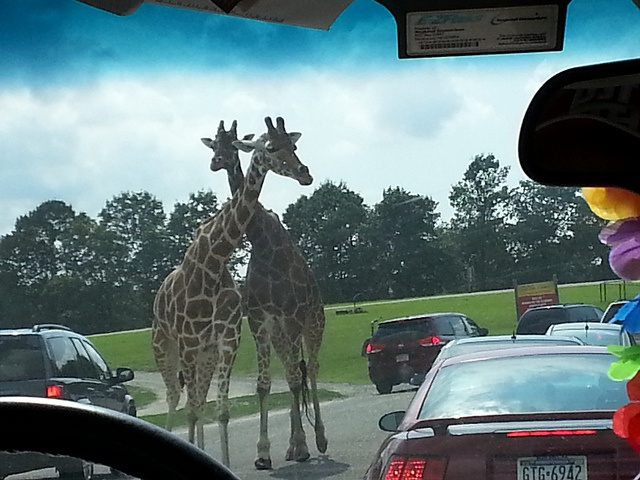Describe the objects in this image and their specific colors. I can see car in darkblue, black, lightblue, and gray tones, giraffe in darkblue, gray, black, and darkgray tones, giraffe in darkblue, gray, black, purple, and darkgray tones, car in darkblue, black, gray, white, and darkgray tones, and car in darkblue, black, purple, gray, and darkgray tones in this image. 